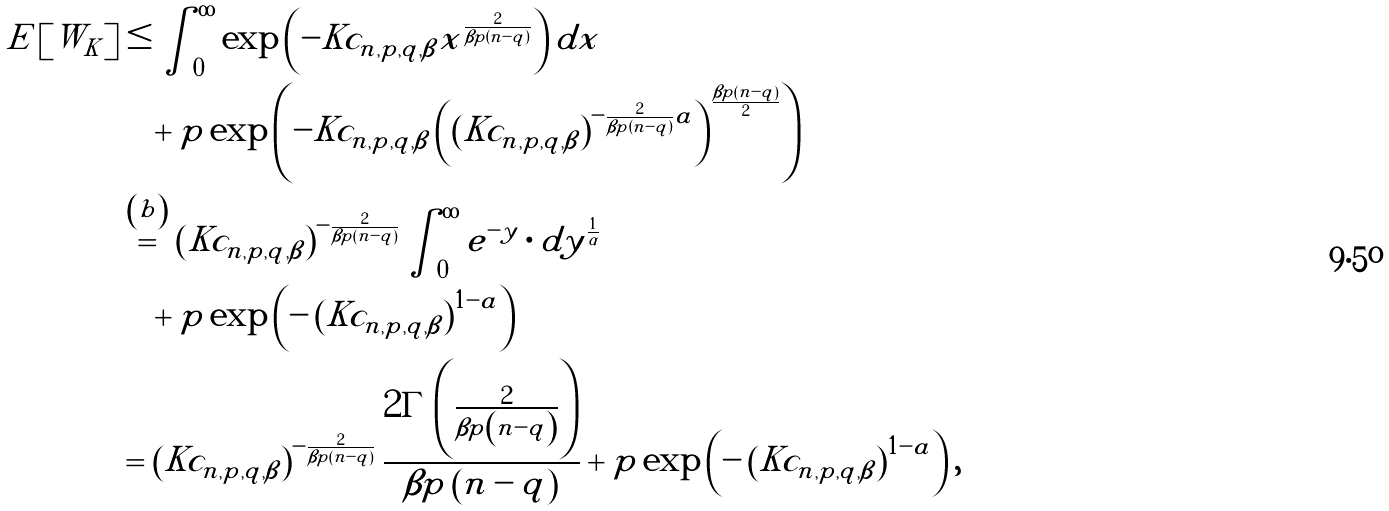<formula> <loc_0><loc_0><loc_500><loc_500>E \left [ W _ { K } \right ] & \leq \int _ { 0 } ^ { \infty } \exp \left ( - K c _ { n , p , q , \beta } x ^ { \frac { 2 } { \beta p \left ( n - q \right ) } } \right ) d x \\ & \quad + p \exp \left ( - K c _ { n , p , q , \beta } \left ( \left ( K c _ { n , p , q , \beta } \right ) ^ { - \frac { 2 } { \beta p \left ( n - q \right ) } a } \right ) ^ { \frac { \beta p \left ( n - q \right ) } { 2 } } \right ) \\ & \overset { \left ( b \right ) } { = } \left ( K c _ { n , p , q , \beta } \right ) ^ { - \frac { 2 } { \beta p \left ( n - q \right ) } } \int _ { 0 } ^ { \infty } e ^ { - y } \cdot d y ^ { \frac { 1 } { \alpha } } \\ & \quad + p \exp \left ( - \left ( K c _ { n , p , q , \beta } \right ) ^ { 1 - a } \right ) \\ & = \left ( K c _ { n , p , q , \beta } \right ) ^ { - \frac { 2 } { \beta p \left ( n - q \right ) } } \frac { 2 \Gamma \left ( \frac { 2 } { \beta p \left ( n - q \right ) } \right ) } { \beta p \left ( n - q \right ) } + p \exp \left ( - \left ( K c _ { n , p , q , \beta } \right ) ^ { 1 - a } \right ) ,</formula> 